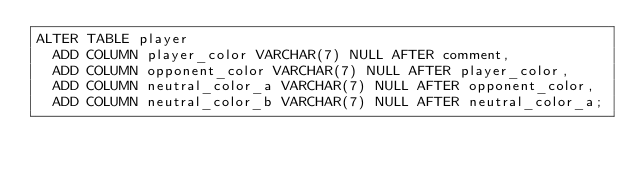Convert code to text. <code><loc_0><loc_0><loc_500><loc_500><_SQL_>ALTER TABLE player
  ADD COLUMN player_color VARCHAR(7) NULL AFTER comment,
  ADD COLUMN opponent_color VARCHAR(7) NULL AFTER player_color,
  ADD COLUMN neutral_color_a VARCHAR(7) NULL AFTER opponent_color,
  ADD COLUMN neutral_color_b VARCHAR(7) NULL AFTER neutral_color_a;
</code> 